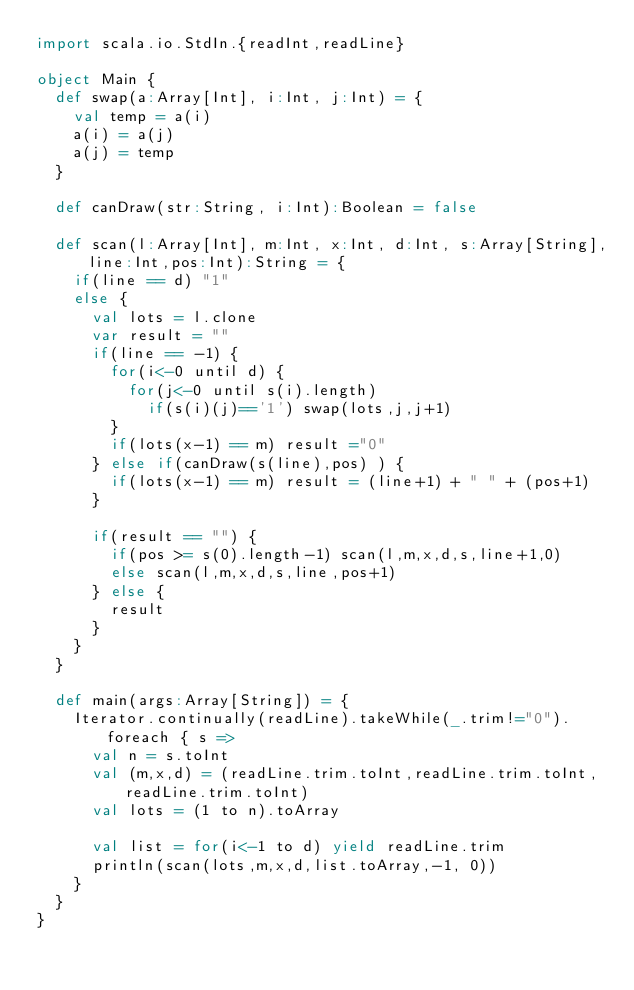<code> <loc_0><loc_0><loc_500><loc_500><_Scala_>import scala.io.StdIn.{readInt,readLine}

object Main {
  def swap(a:Array[Int], i:Int, j:Int) = {
    val temp = a(i)
    a(i) = a(j)
    a(j) = temp
  }

  def canDraw(str:String, i:Int):Boolean = false

  def scan(l:Array[Int], m:Int, x:Int, d:Int, s:Array[String],line:Int,pos:Int):String = {
    if(line == d) "1"
    else {
      val lots = l.clone
      var result = ""
      if(line == -1) {
        for(i<-0 until d) {
          for(j<-0 until s(i).length)
            if(s(i)(j)=='1') swap(lots,j,j+1)
        }
        if(lots(x-1) == m) result ="0"
      } else if(canDraw(s(line),pos) ) {
        if(lots(x-1) == m) result = (line+1) + " " + (pos+1)
      }

      if(result == "") {
        if(pos >= s(0).length-1) scan(l,m,x,d,s,line+1,0)
        else scan(l,m,x,d,s,line,pos+1)
      } else {
        result
      }
    }
  }

  def main(args:Array[String]) = {
    Iterator.continually(readLine).takeWhile(_.trim!="0").foreach { s =>
      val n = s.toInt
      val (m,x,d) = (readLine.trim.toInt,readLine.trim.toInt,readLine.trim.toInt)
      val lots = (1 to n).toArray

      val list = for(i<-1 to d) yield readLine.trim
      println(scan(lots,m,x,d,list.toArray,-1, 0))
    }
  }
}</code> 